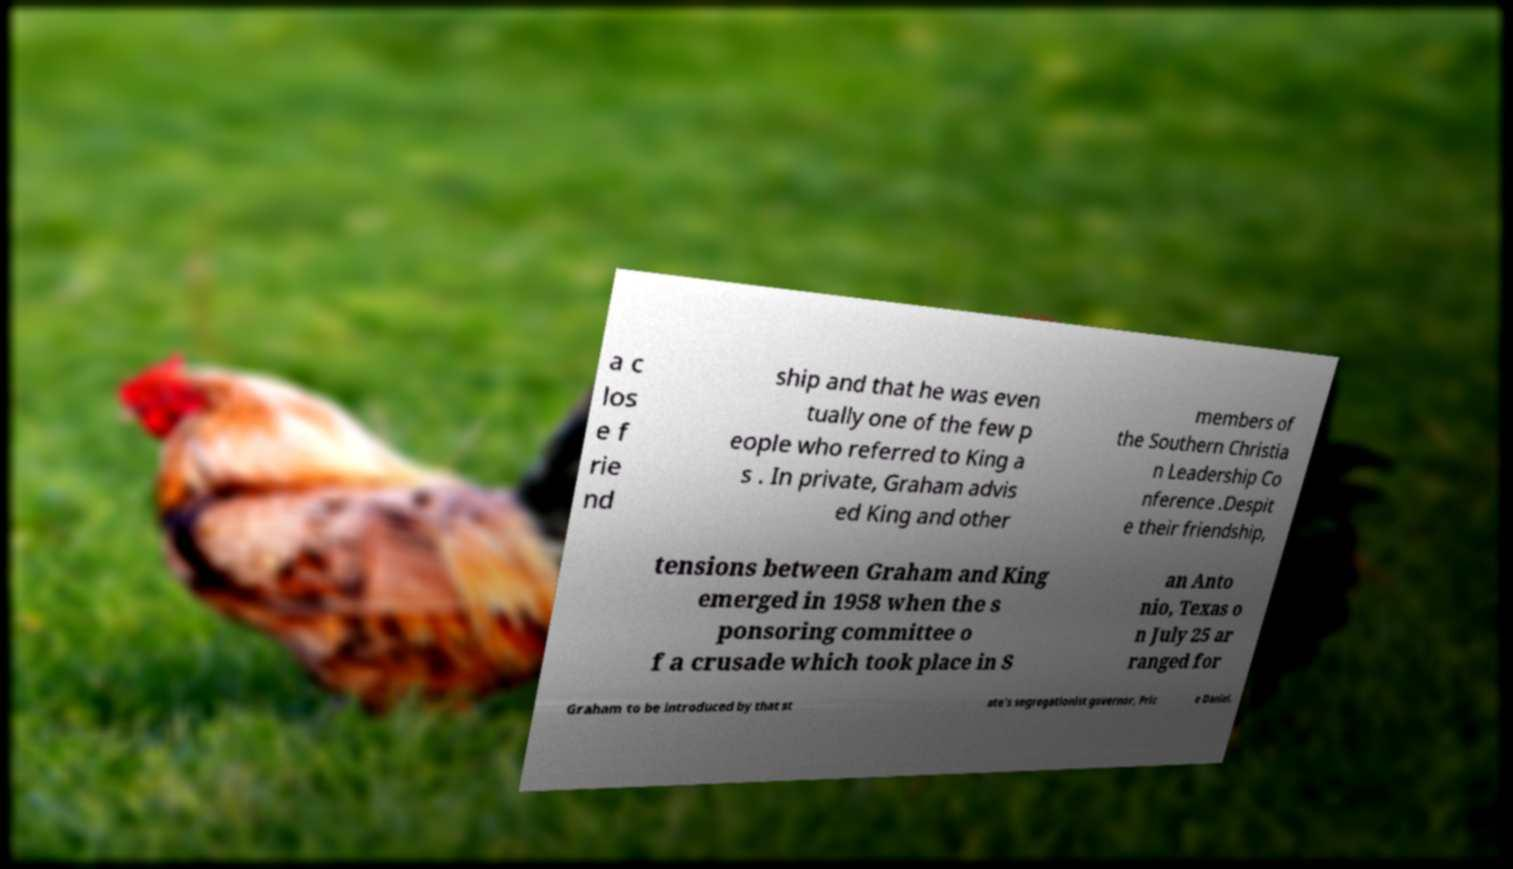Please read and relay the text visible in this image. What does it say? a c los e f rie nd ship and that he was even tually one of the few p eople who referred to King a s . In private, Graham advis ed King and other members of the Southern Christia n Leadership Co nference .Despit e their friendship, tensions between Graham and King emerged in 1958 when the s ponsoring committee o f a crusade which took place in S an Anto nio, Texas o n July 25 ar ranged for Graham to be introduced by that st ate's segregationist governor, Pric e Daniel. 